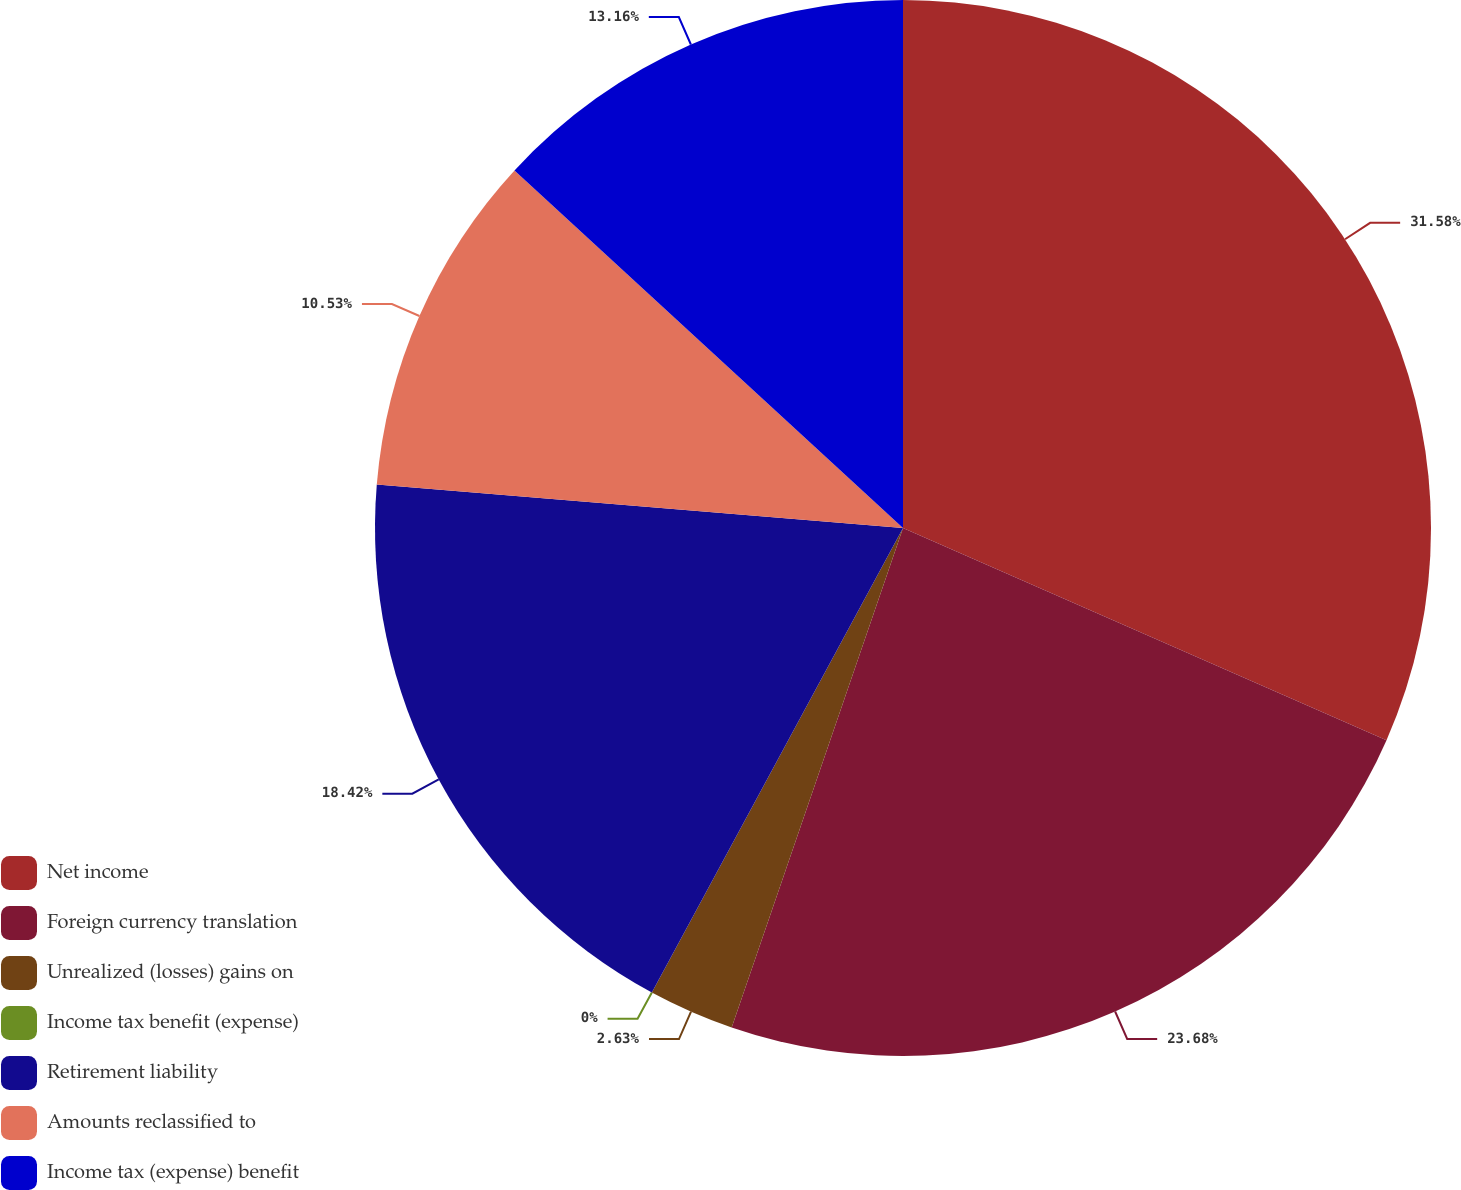Convert chart to OTSL. <chart><loc_0><loc_0><loc_500><loc_500><pie_chart><fcel>Net income<fcel>Foreign currency translation<fcel>Unrealized (losses) gains on<fcel>Income tax benefit (expense)<fcel>Retirement liability<fcel>Amounts reclassified to<fcel>Income tax (expense) benefit<nl><fcel>31.58%<fcel>23.68%<fcel>2.63%<fcel>0.0%<fcel>18.42%<fcel>10.53%<fcel>13.16%<nl></chart> 